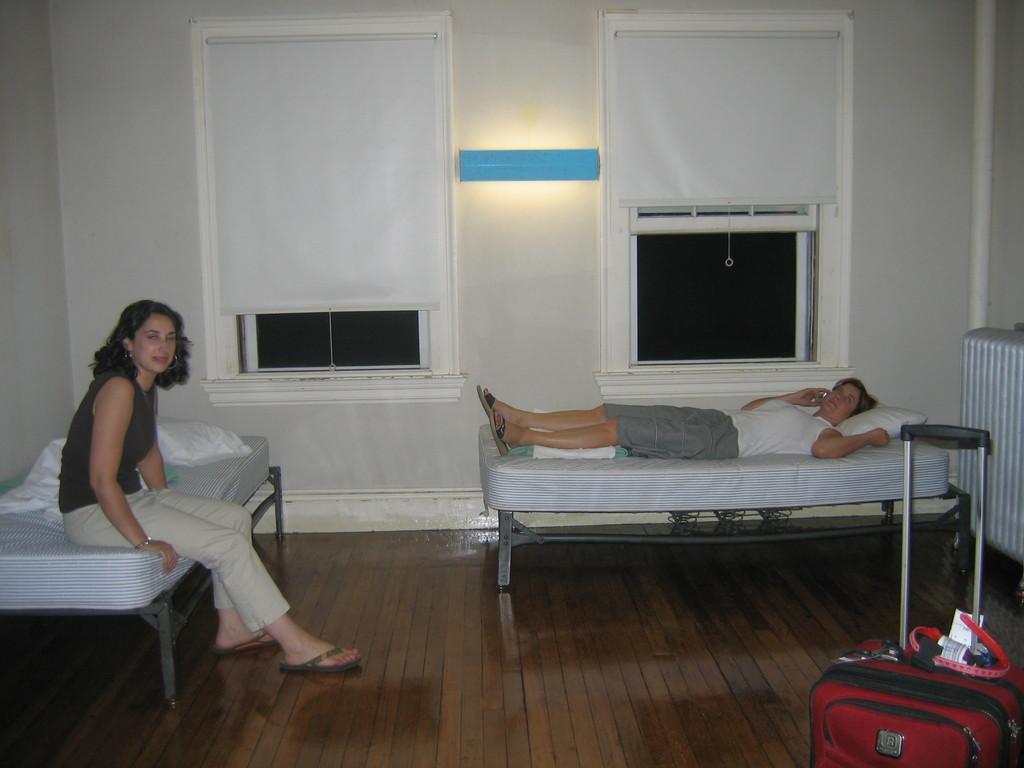Can you describe this image briefly? In the image we can see there is a person who is lying on the bed another woman is sitting on the bed. 